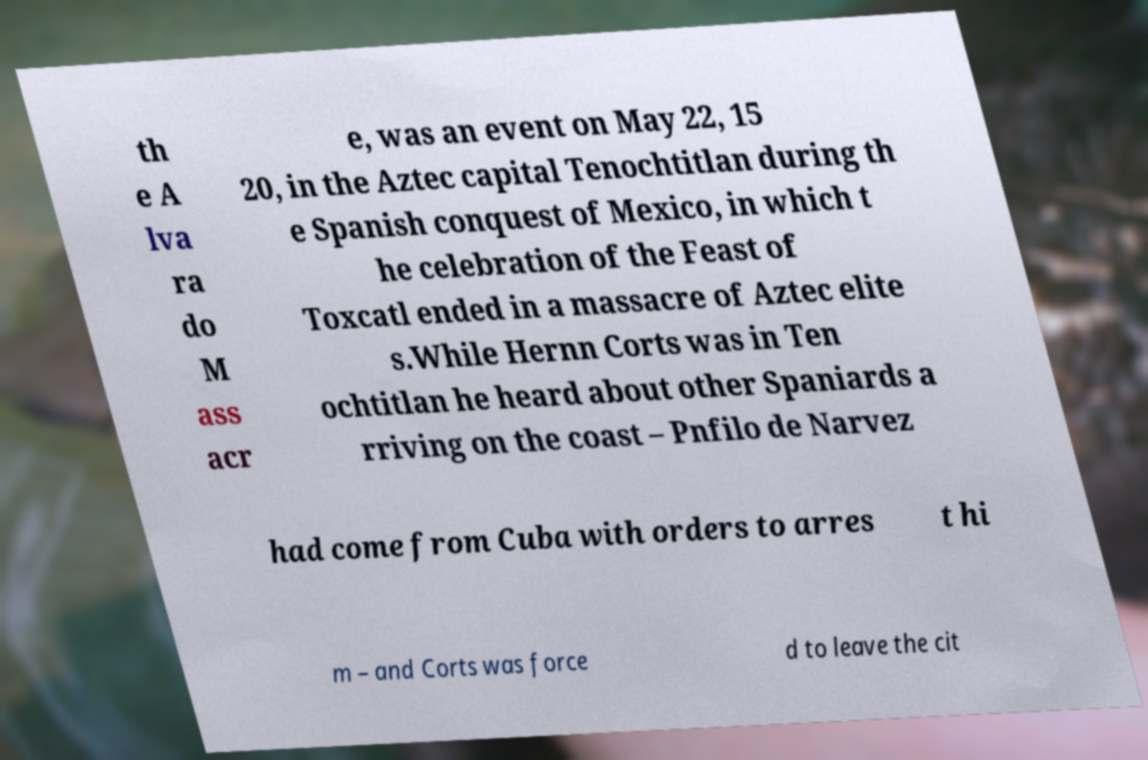Can you read and provide the text displayed in the image?This photo seems to have some interesting text. Can you extract and type it out for me? th e A lva ra do M ass acr e, was an event on May 22, 15 20, in the Aztec capital Tenochtitlan during th e Spanish conquest of Mexico, in which t he celebration of the Feast of Toxcatl ended in a massacre of Aztec elite s.While Hernn Corts was in Ten ochtitlan he heard about other Spaniards a rriving on the coast – Pnfilo de Narvez had come from Cuba with orders to arres t hi m – and Corts was force d to leave the cit 